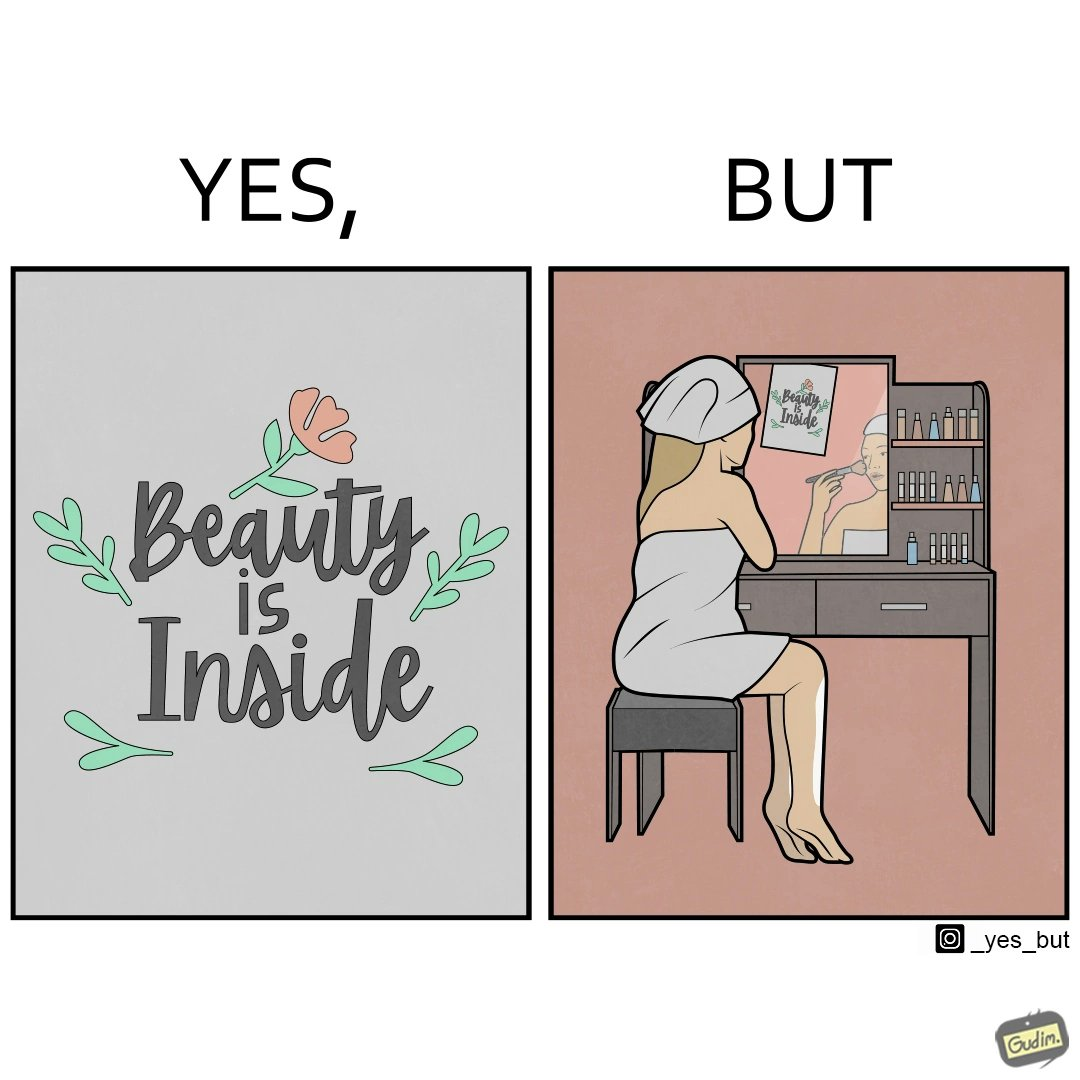Describe what you see in this image. The image is satirical because while the text on the paper says that beauty lies inside, the woman ignores the note and continues to apply makeup to improve her outer beauty. 